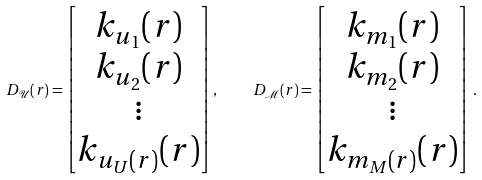<formula> <loc_0><loc_0><loc_500><loc_500>D _ { \mathcal { U } } ( r ) = \begin{bmatrix} k _ { u _ { 1 } } ( r ) \\ k _ { u _ { 2 } } ( r ) \\ \vdots \\ k _ { u _ { U } ( r ) } ( r ) \end{bmatrix} , \quad D _ { \mathcal { M } } ( r ) = \begin{bmatrix} k _ { m _ { 1 } } ( r ) \\ k _ { m _ { 2 } } ( r ) \\ \vdots \\ k _ { m _ { M } ( r ) } ( r ) \end{bmatrix} \, .</formula> 